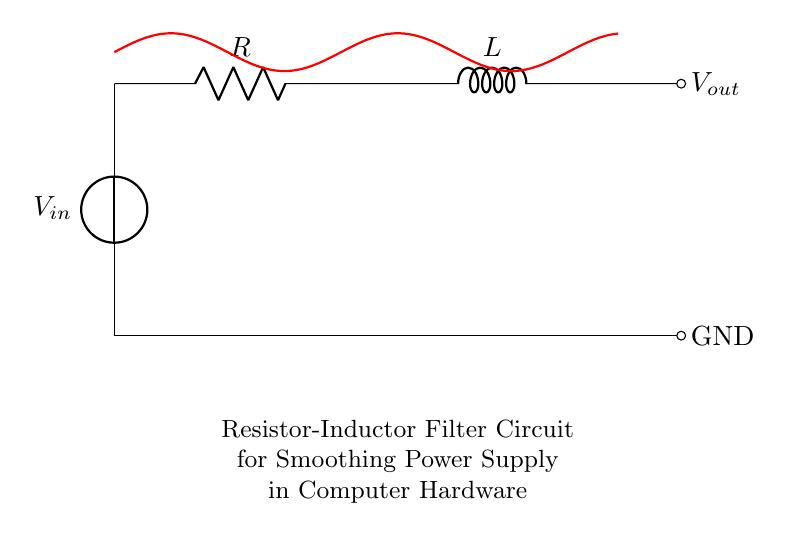What is the input voltage in the circuit? The input voltage is represented by \( V_{in} \) in the circuit diagram and is located at the top left as the voltage source.
Answer: \( V_{in} \) What components are present in the circuit? The components present in the circuit are a resistor \( R \) and an inductor \( L \), which are depicted in the diagram, along with a voltage source.
Answer: Resistor and Inductor What is the purpose of the resistor in this circuit? The resistor in the circuit helps to limit the current flowing through the inductor and also plays a role in the time constant of the filter.
Answer: Current Limiting What is the effect of the inductor on the output voltage? The inductor smooths out the fluctuations in the output voltage \( V_{out} \), providing a more stable DC output by opposing changes in current.
Answer: Smoothing What is the relationship between the resistor and inductor in filtering? The resistor and inductor work together to define the cutoff frequency of the filter, with the inductor providing inductive reactance and the resistor providing resistance.
Answer: Cutoff Frequency How does this circuit improve power supply stability? This circuit improves power supply stability by filtering high-frequency noise and providing a smoother output voltage by integrating the rapid voltage variations.
Answer: Filtering Noise 